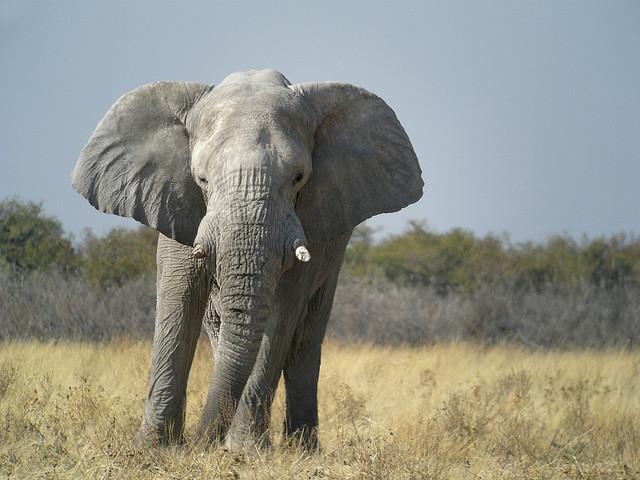Which way is the elephant learning?
Write a very short answer. Left. Does the elephant have long tusk?
Be succinct. No. Is the grass green?
Short answer required. No. 